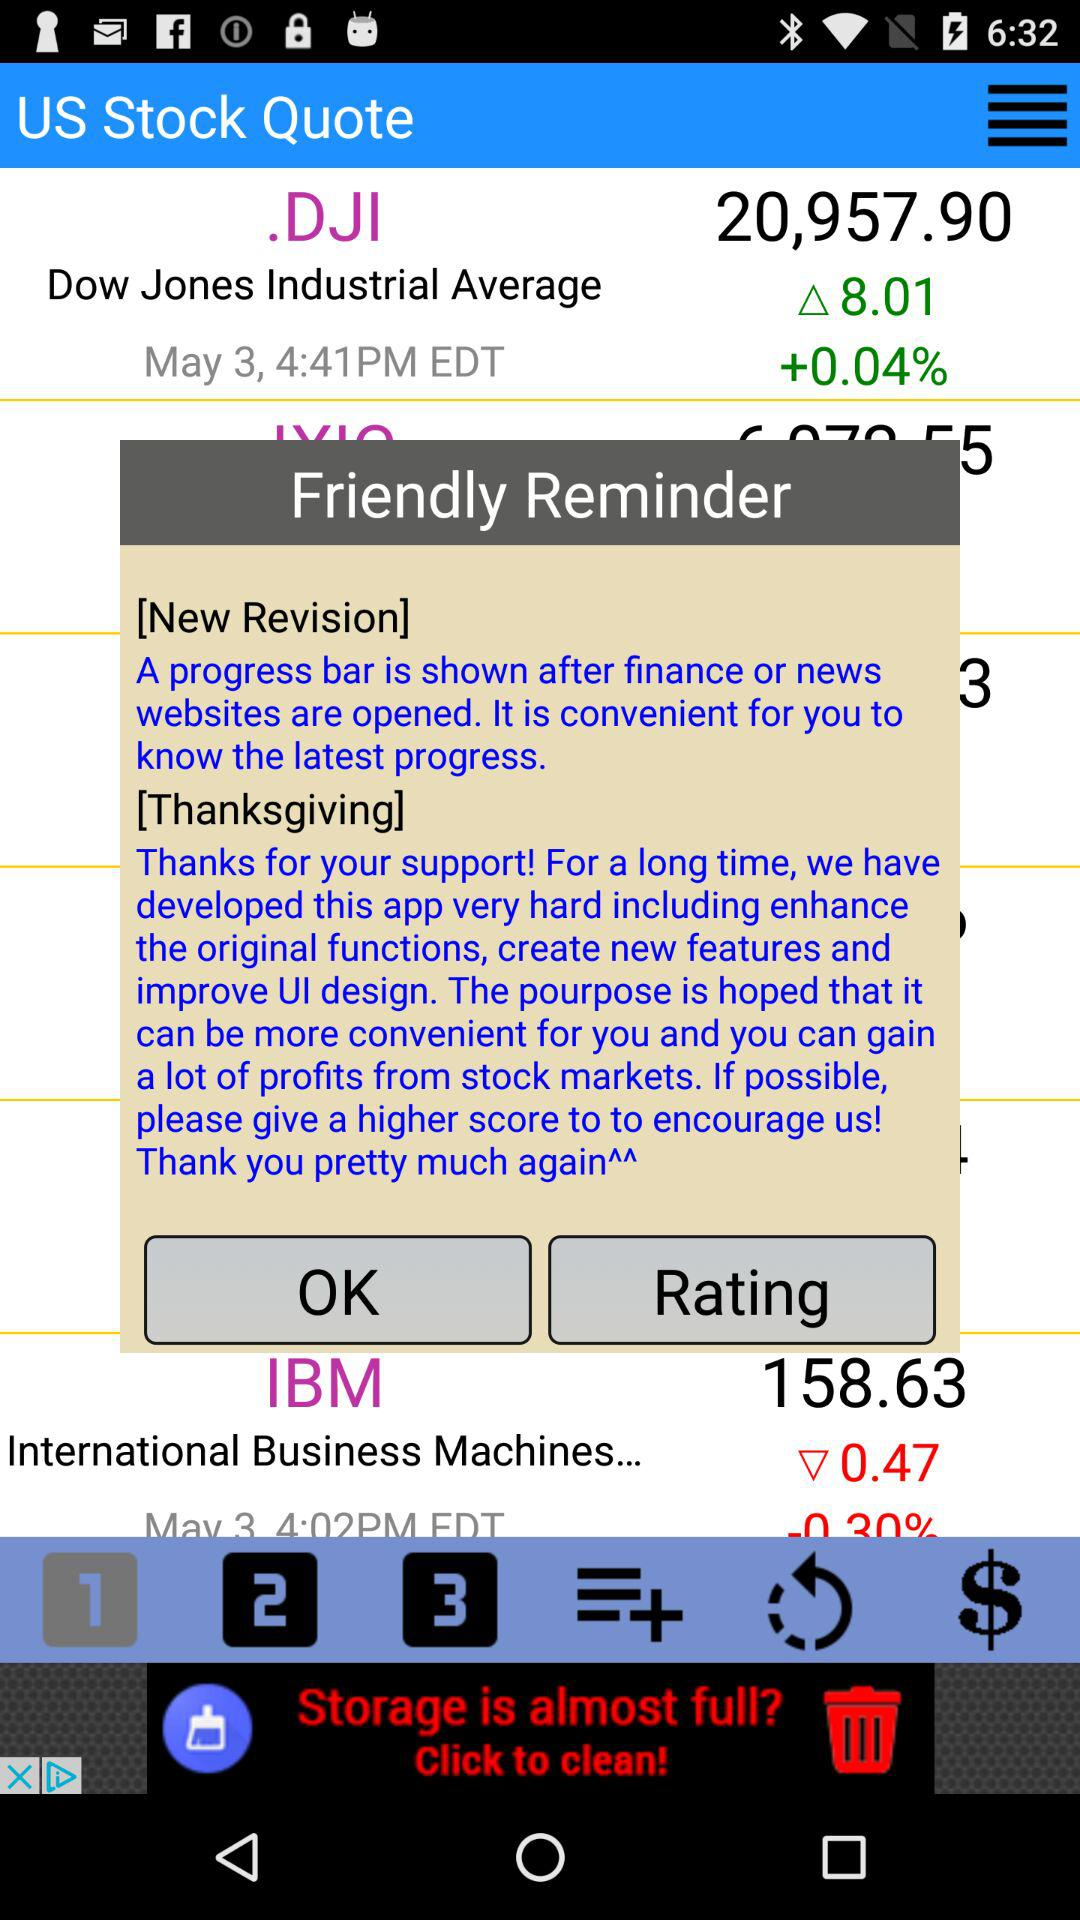What is the percentage loss on stock price of IBM?
When the provided information is insufficient, respond with <no answer>. <no answer> 